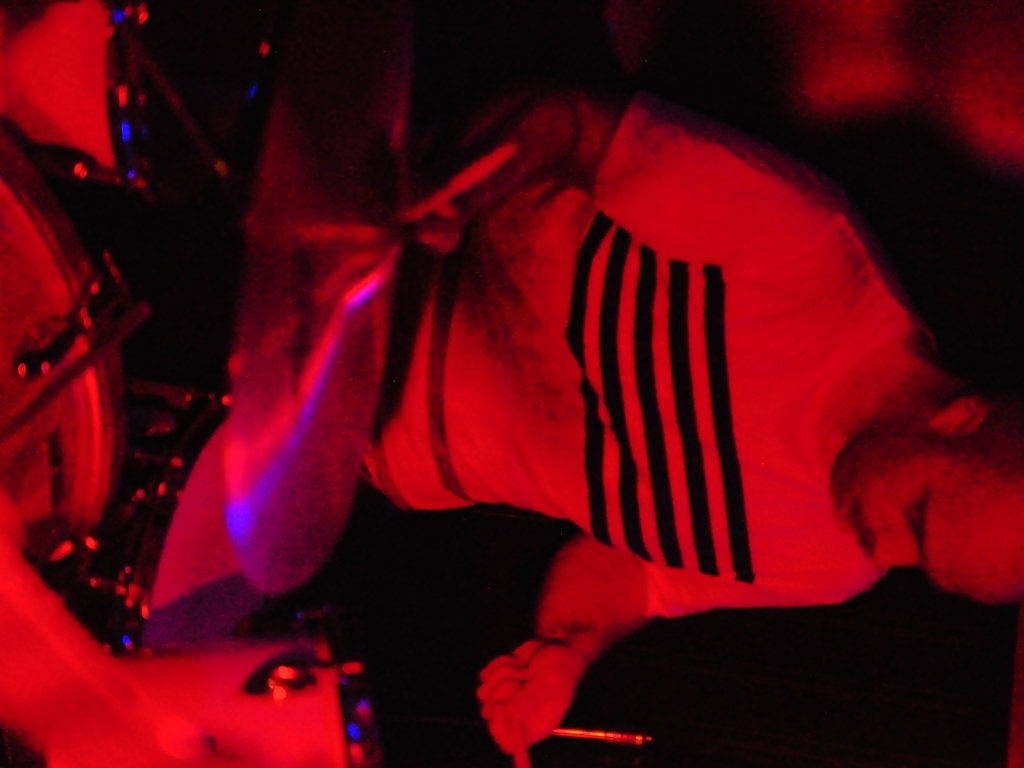What activity might be taking place here? Given the equipment visible and the pose of the blurred figure, it's likely a live music performance, with the individual potentially playing drums or another instrument that requires significant movement. 